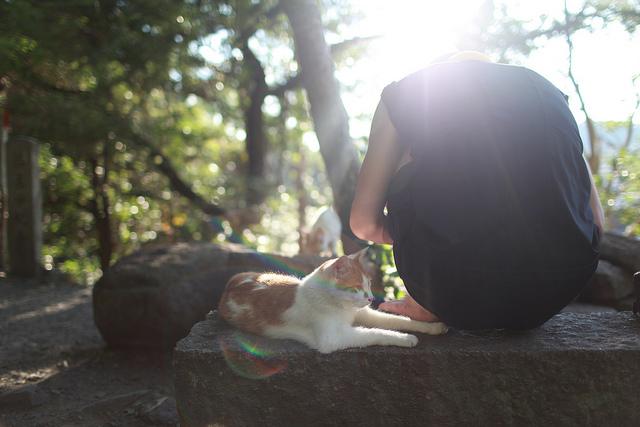Where is a barefoot?
Keep it brief. By cat. Was this photo taken indoors?
Be succinct. No. What kind of animal is the person sitting next to?
Concise answer only. Cat. 